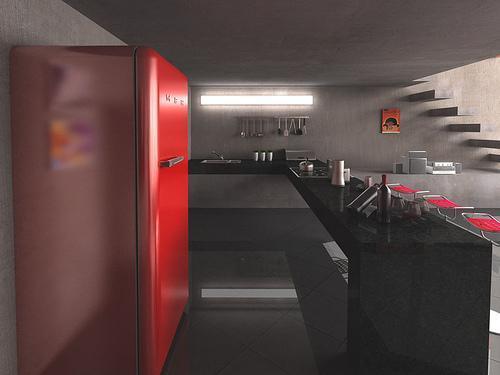How many full steps can you see?
Give a very brief answer. 3. 